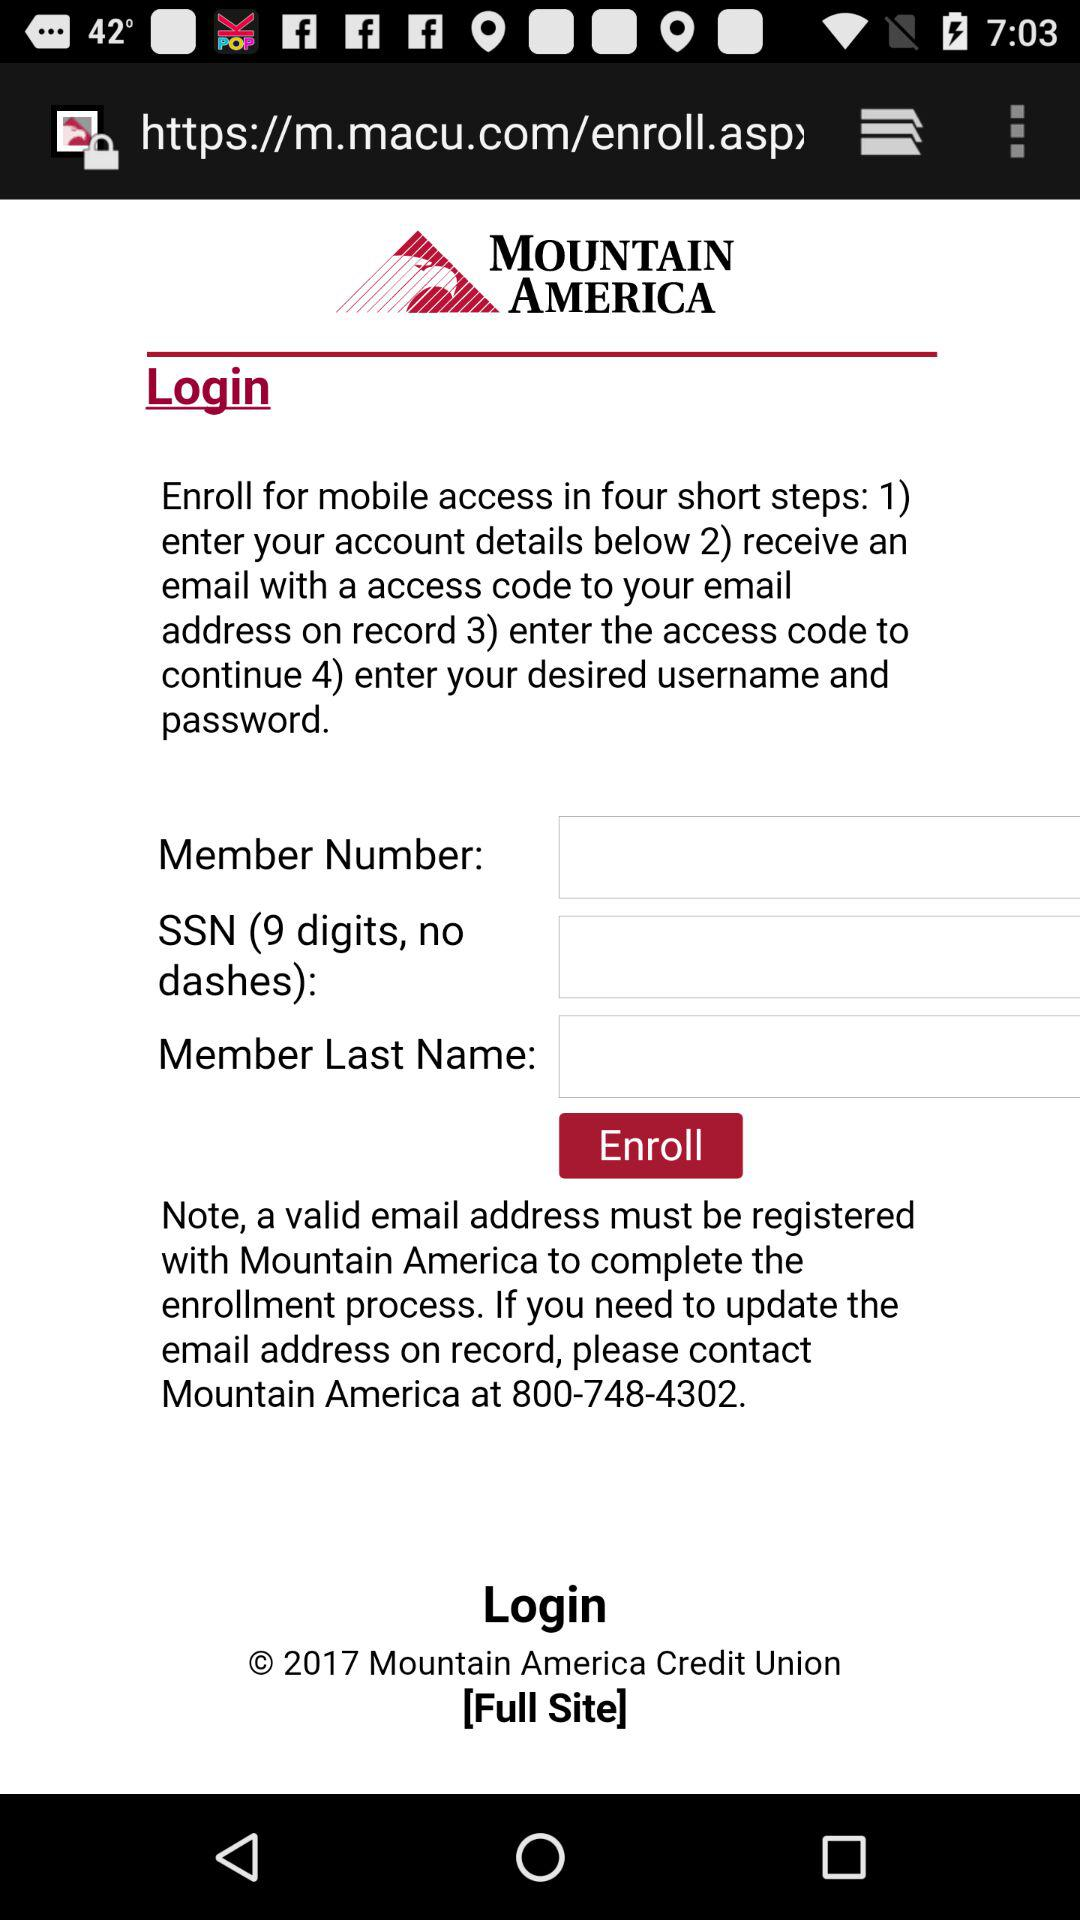What is the name of the application? The name of the application is "Mountain America Credit Union". 